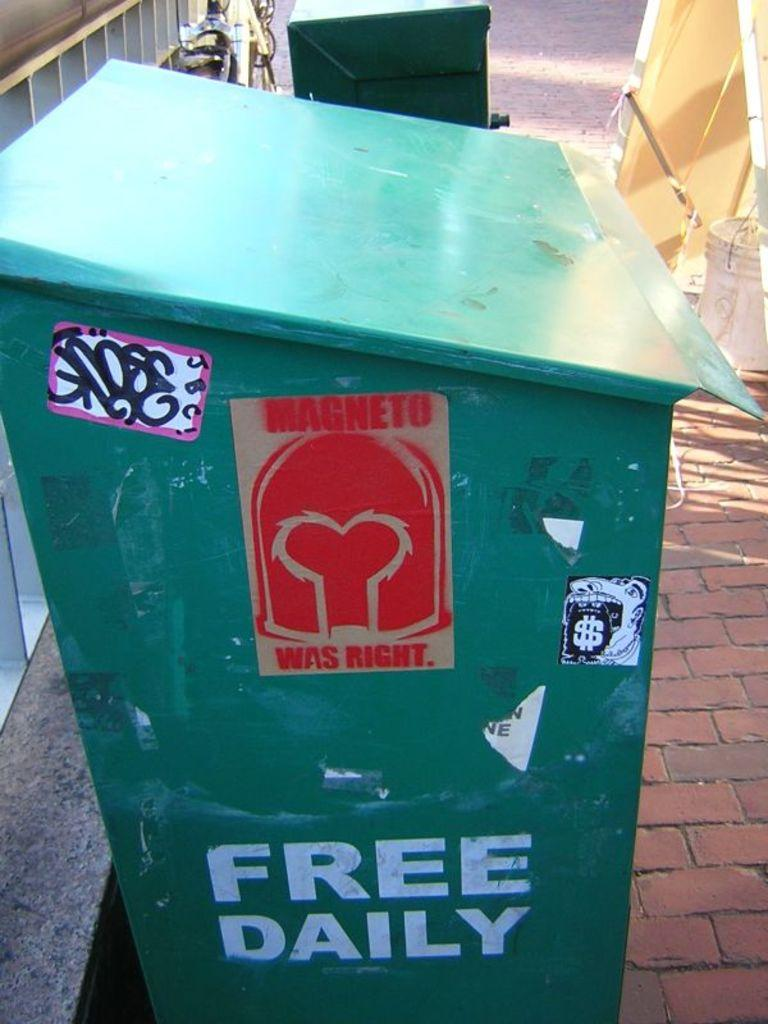<image>
Offer a succinct explanation of the picture presented. Free daily sign and magneto was right sign on a green can 